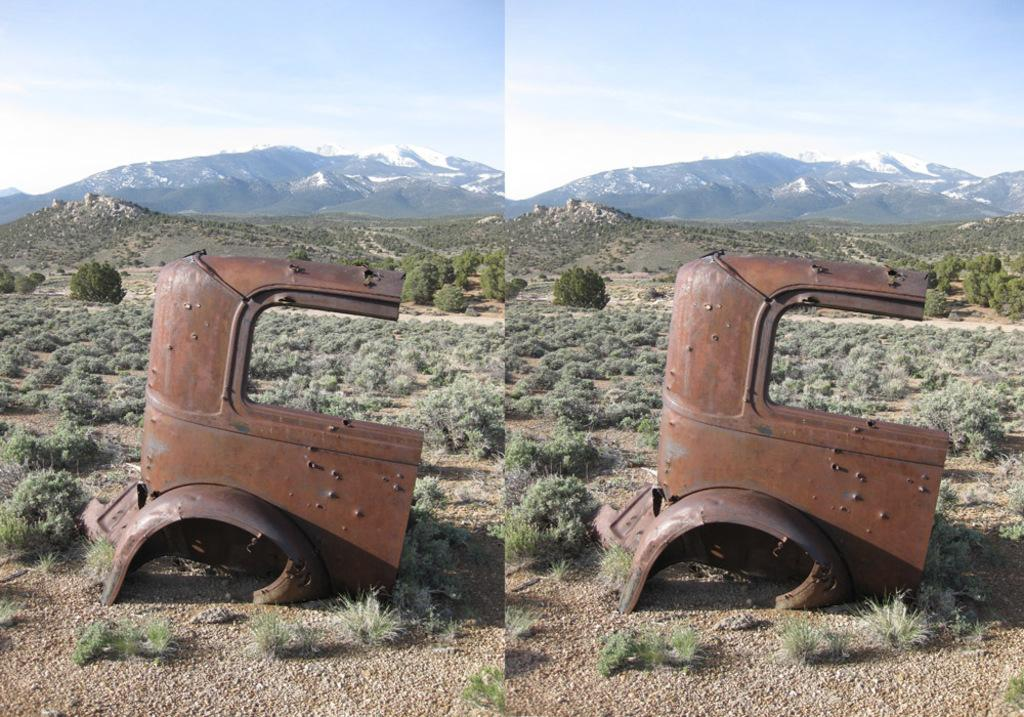What type of image is shown in the picture? The image is an edited image. What can be observed in the edited image? There are two identical images in the edited image. What type of vegetation is present at the bottom of the image? There are bushes at the bottom of the image. What type of natural formation is in the middle of the image? There are mountains in the middle of the image. What is visible at the top of the image? The sky is visible at the top of the image. What type of vessel is present in the image? There is no vessel present in the image. What type of vase can be seen holding flowers in the image? There is no vase or flowers present in the image. 